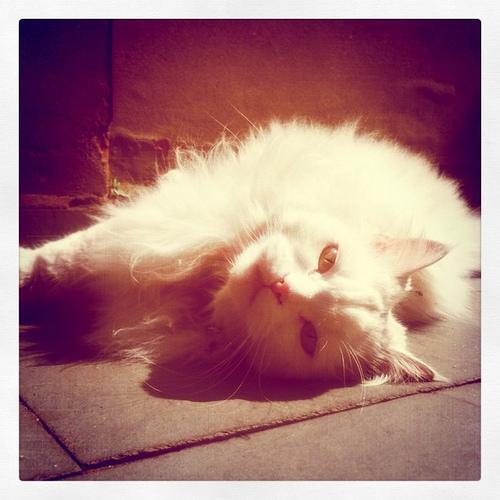How many cats are there?
Give a very brief answer. 1. 